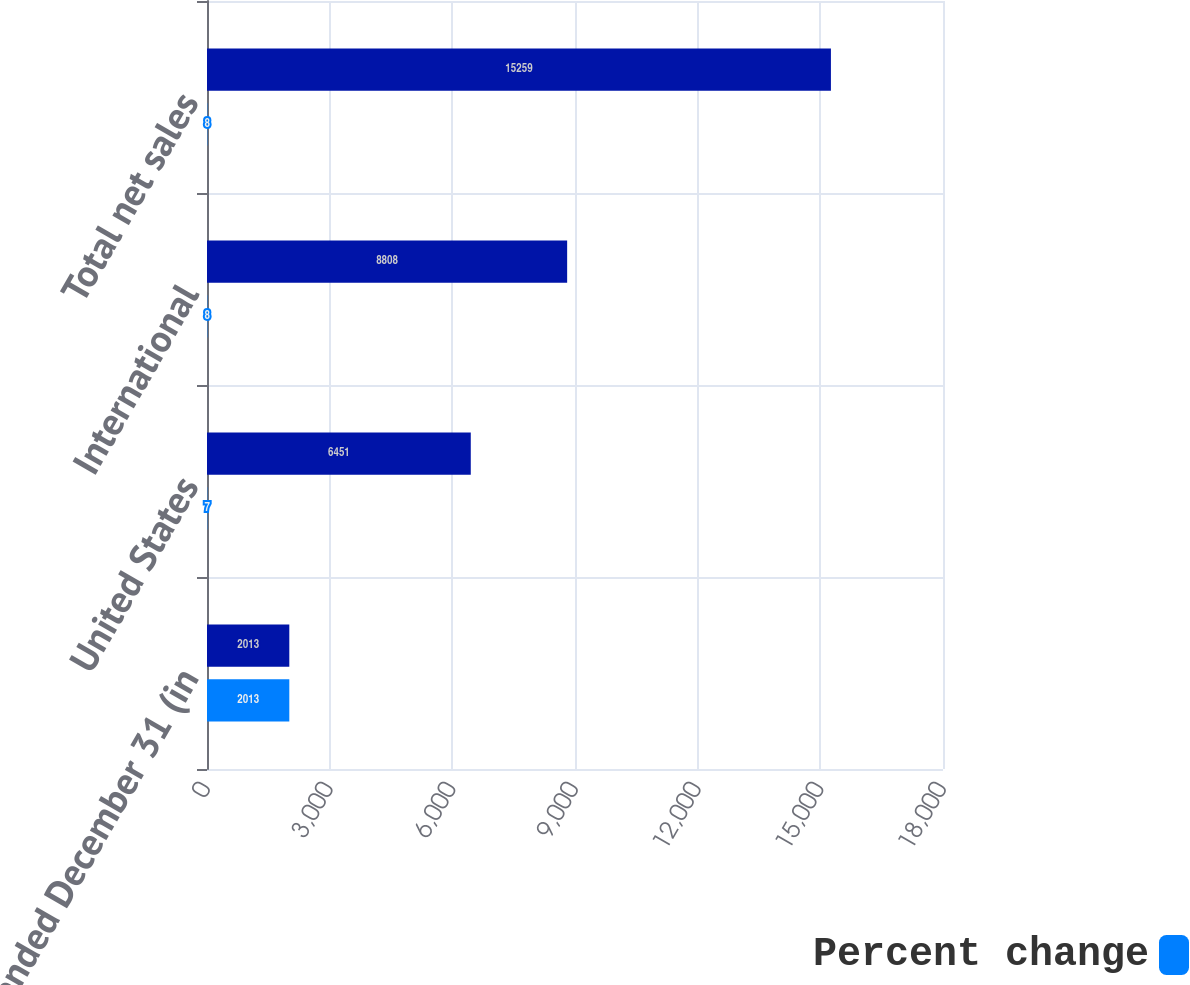<chart> <loc_0><loc_0><loc_500><loc_500><stacked_bar_chart><ecel><fcel>years ended December 31 (in<fcel>United States<fcel>International<fcel>Total net sales<nl><fcel>nan<fcel>2013<fcel>6451<fcel>8808<fcel>15259<nl><fcel>Percent change<fcel>2013<fcel>7<fcel>8<fcel>8<nl></chart> 